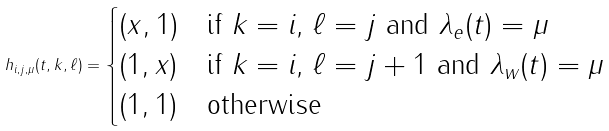<formula> <loc_0><loc_0><loc_500><loc_500>h _ { i , j , \mu } ( t , k , \ell ) = \begin{cases} ( x , 1 ) & \text {if $k = i$, $\ell = j$ and $\lambda_{e}(t) = \mu$} \\ ( 1 , x ) & \text {if $k = i$, $\ell = j+1$ and $\lambda_{w}(t) = \mu$} \\ ( 1 , 1 ) & \text {otherwise} \end{cases}</formula> 